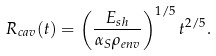Convert formula to latex. <formula><loc_0><loc_0><loc_500><loc_500>R _ { c a v } ( t ) = \left ( \frac { E _ { s h } } { \alpha _ { S } \rho _ { e n v } } \right ) ^ { 1 / 5 } t ^ { 2 / 5 } .</formula> 